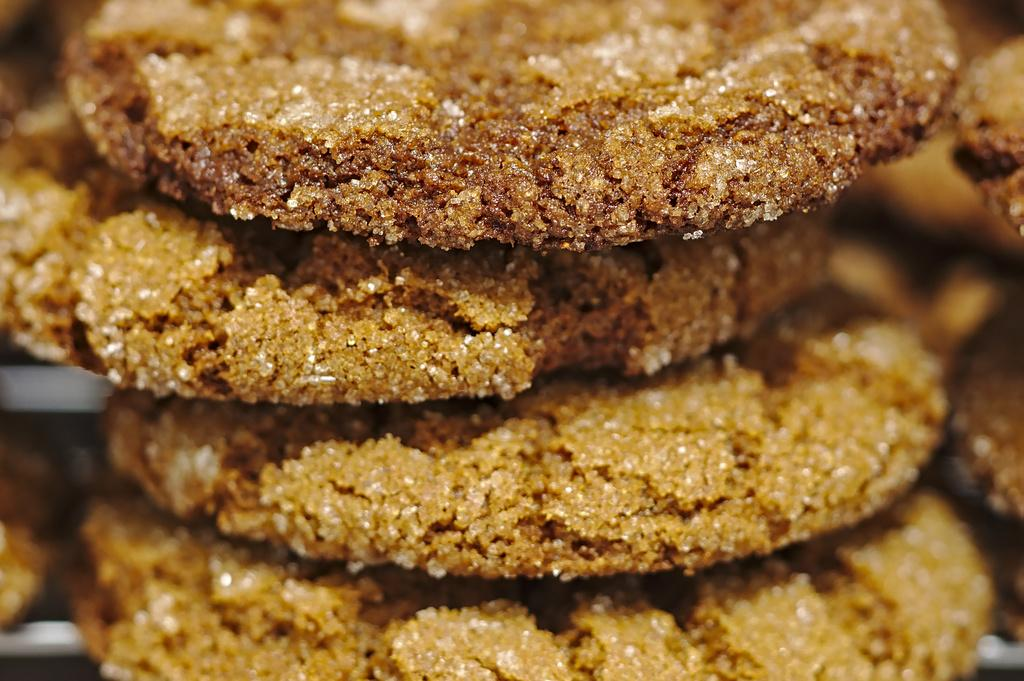What type of food can be seen in the image? There are cookies in the image. What direction are the cookies facing in the image? The cookies do not have a specific direction they are facing, as they are not depicted as having a front or back side. 